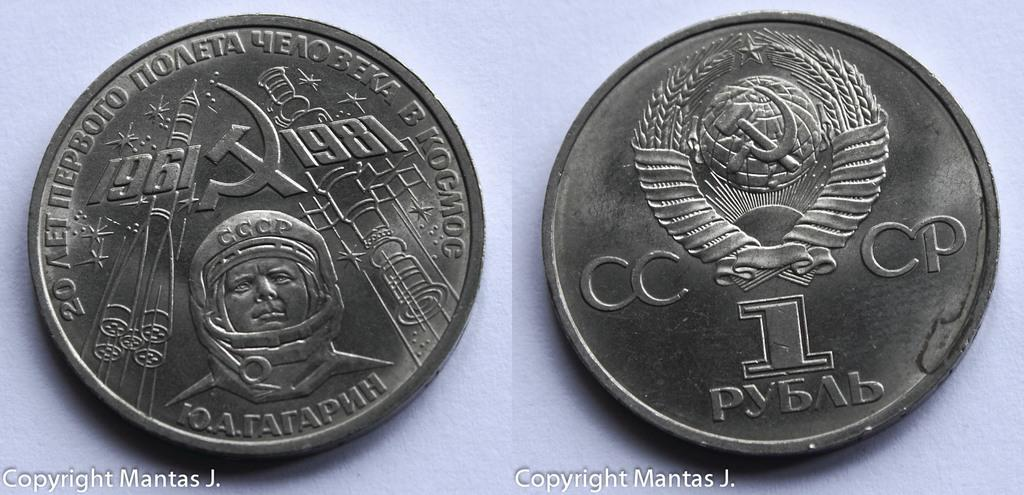<image>
Describe the image concisely. A 1981 CCCP coin commemorates a space event from 1961. 